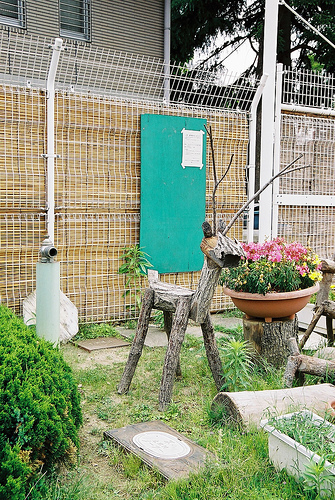<image>
Is there a fence behind the plant? Yes. From this viewpoint, the fence is positioned behind the plant, with the plant partially or fully occluding the fence. 